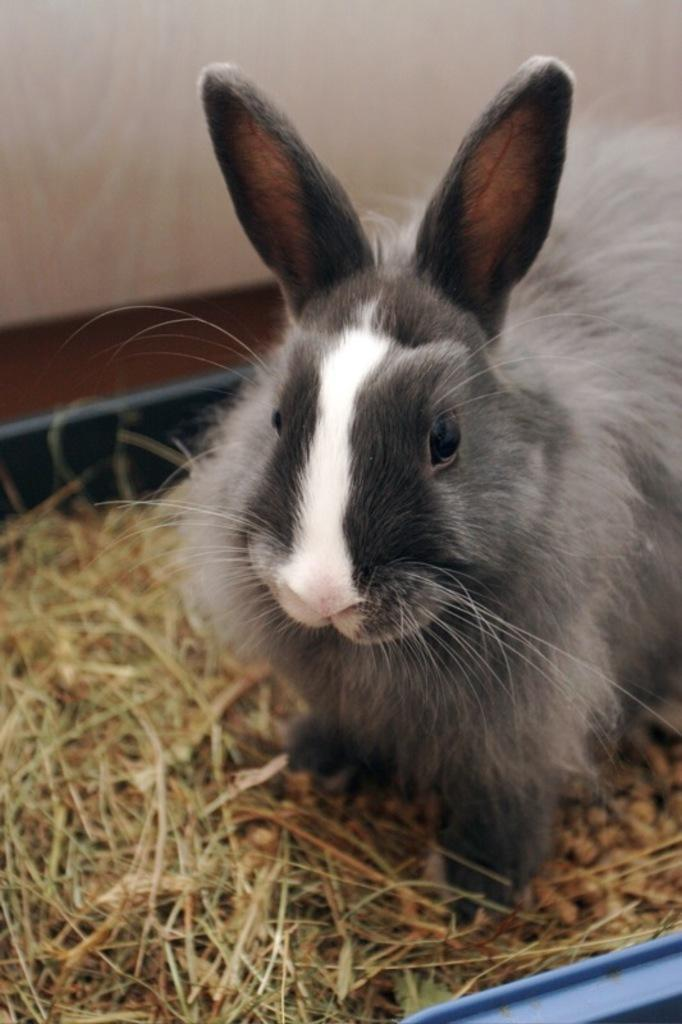What animal is present in the image? There is a rabbit in the image. Where is the rabbit located? The rabbit is on the grass. What is the grass placed in? The grass is placed in a blue color tub. What can be seen in the background of the image? There is a wall in the background of the image. What type of bait is the rabbit using to catch fish in the image? There is no indication of fishing or bait in the image; it features a rabbit on the grass in a blue color tub. What color is the rabbit's polish in the image? Rabbits do not wear polish, and there is no mention of polish in the image. 